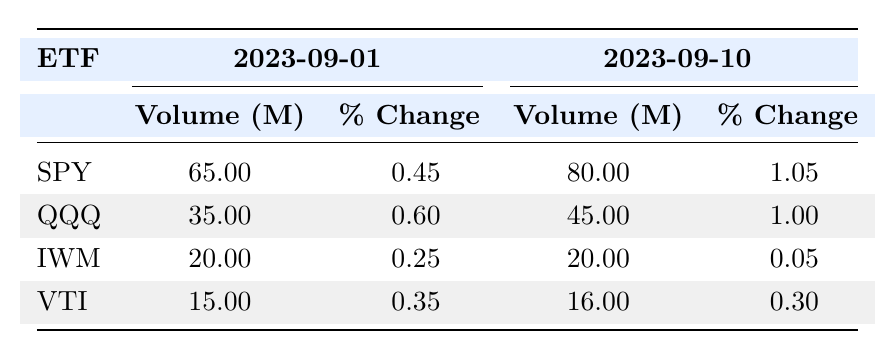What was the trading volume of SPY on September 10, 2023? From the table, the volume for SPY on September 10 is directly listed under "Volume (M)" for that date, which shows 80.00 million.
Answer: 80.00 million What percentage change in price did QQQ experience from September 1 to September 10, 2023? The price change on September 1 for QQQ is 0.60 and on September 10 it is 1.00. The difference is calculated as 1.00 - 0.60 = 0.40, indicating a positive change.
Answer: 0.40 Which ETF had the highest trading volume on September 1, 2023? By comparing the trading volumes for each ETF on September 1, SPY has the highest volume of 65.00 million, while the others (QQQ: 35.00, IWM: 20.00, VTI: 15.00) are lower.
Answer: SPY What was the total trading volume of VTI for the entire observed period? To find the total volume for VTI, we add up all the daily volumes: 15 + 13 + 16 + 15 + 15 + 14 + 17 + 16 + 15 + 16 =  151 million.
Answer: 151 million Did IWM see an increase in trading volume from September 1 to September 10, 2023? The volume on September 1 for IWM is 20.00 million and on September 10 it remains 20.00 million, showing no increase.
Answer: No Which ETF had the highest percentage change in price from September 1 to September 10? By reviewing the percentage changes for all ETFs, on September 10, SPY has 1.05 (increase of 0.60), QQQ has 1.00 (increase of 0.40), IWM has 0.05 (decrease of 0.20), and VTI has 0.30 (increase of 0.20). SPY shows the highest increase of 0.60.
Answer: SPY What was the average trading volume of QQQ during the observed period? The total volume is the sum of the daily volumes for QQQ (35000000 + 28000000 + 40000000 + 39000000 + 36000000 + 41000000 + 42000000 + 38000000 + 30000000 + 45000000) = 393000000. Dividing by 10 days results in an average of 39300000.
Answer: 39300000 Is it true that all ETFs experienced a price change greater than or equal to 0.25 between September 1 and September 10? By checking the price changes, both IWM (0.05) and VTI (0.30) have price changes less than 0.25, hence not all ETFs meet this criterion.
Answer: No 